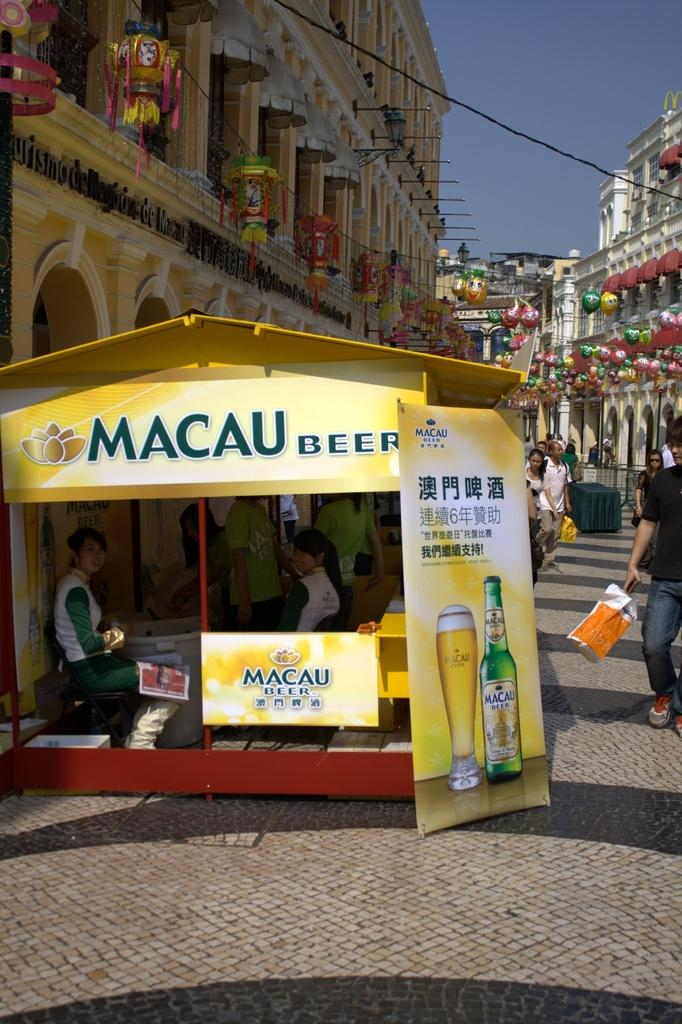<image>
Create a compact narrative representing the image presented. The small stall shown in yellow must sell Macau beer. 